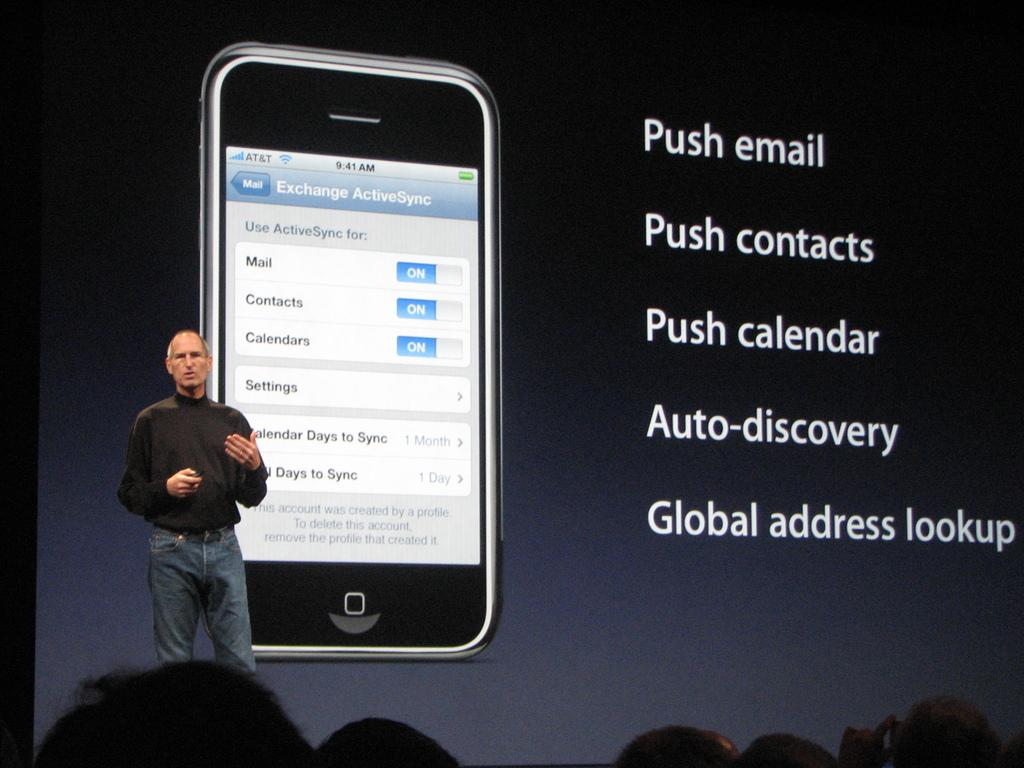<image>
Describe the image concisely. a photo of a phone with Mail written on it 